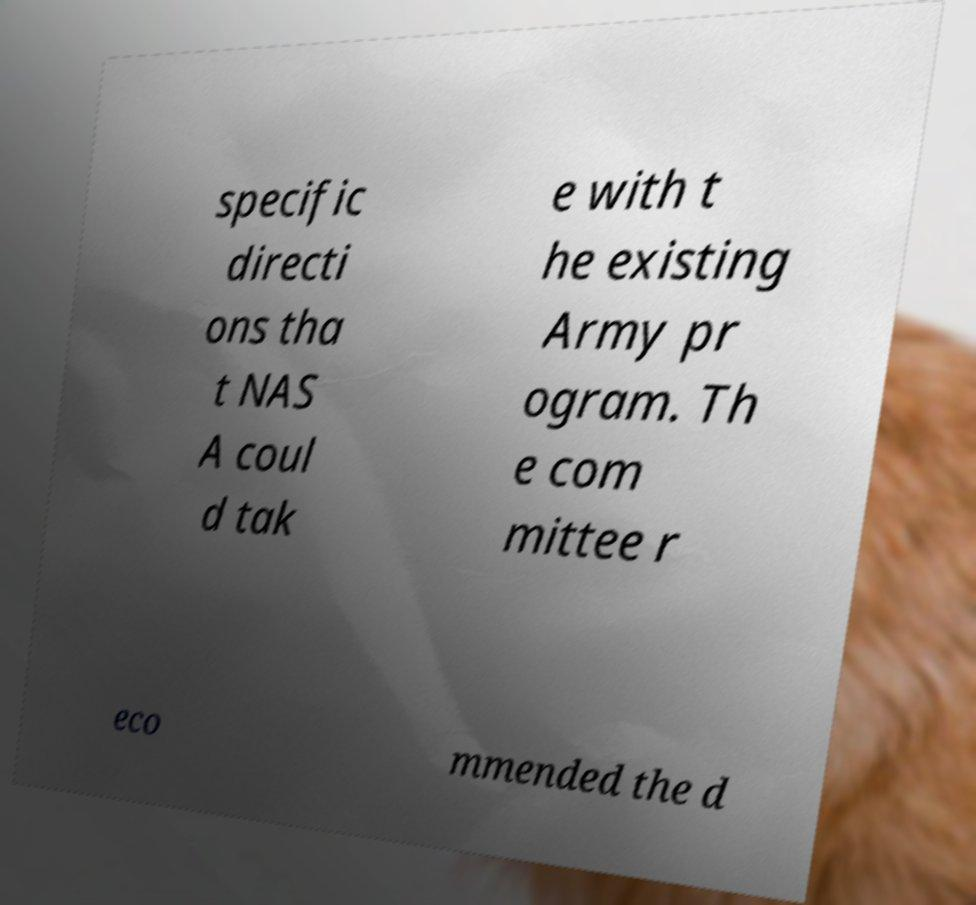What messages or text are displayed in this image? I need them in a readable, typed format. specific directi ons tha t NAS A coul d tak e with t he existing Army pr ogram. Th e com mittee r eco mmended the d 